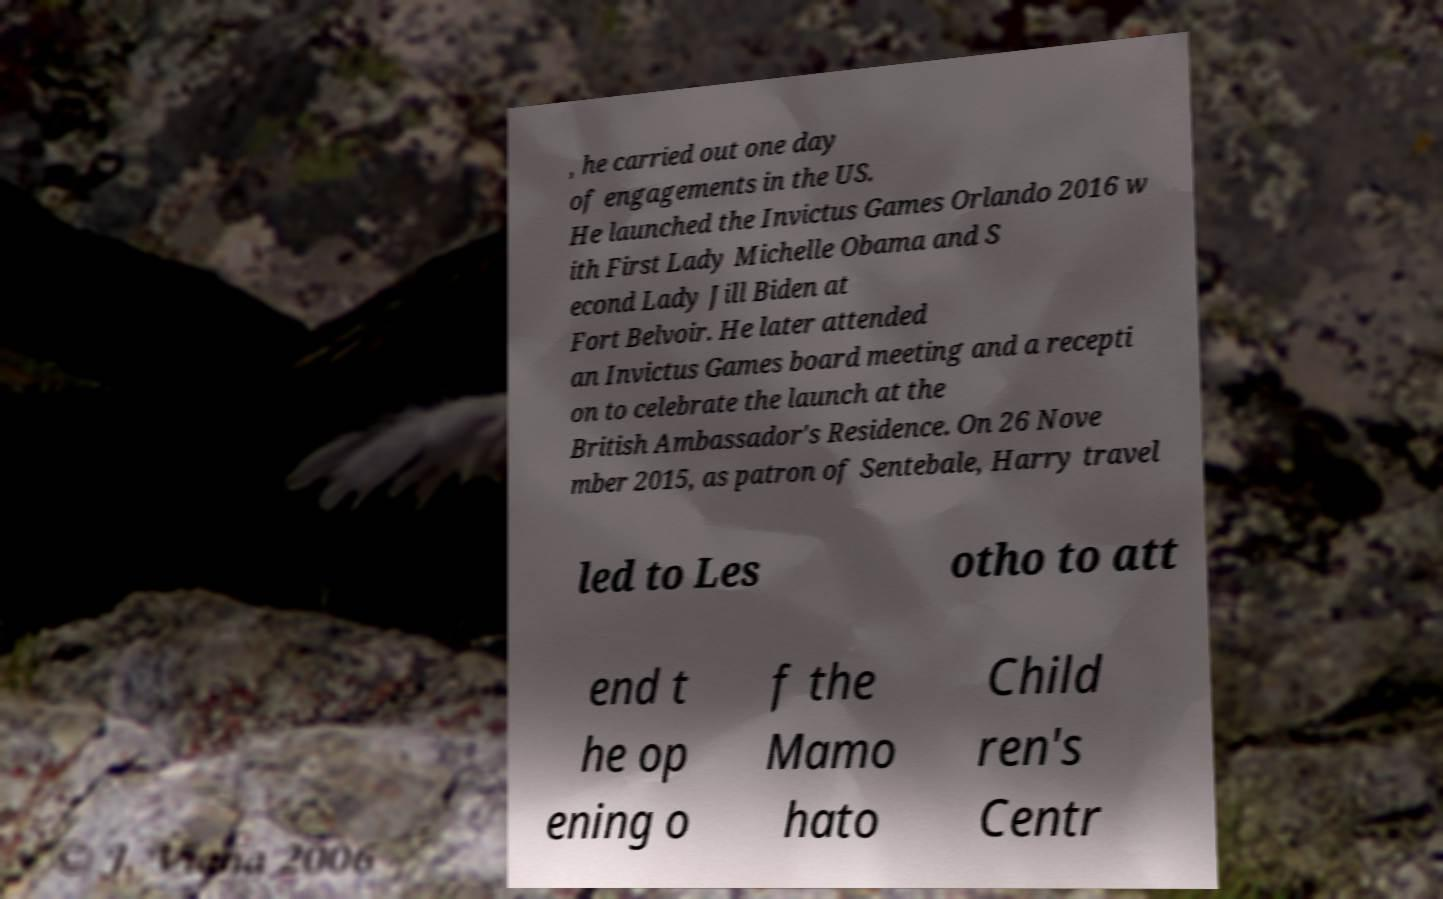I need the written content from this picture converted into text. Can you do that? , he carried out one day of engagements in the US. He launched the Invictus Games Orlando 2016 w ith First Lady Michelle Obama and S econd Lady Jill Biden at Fort Belvoir. He later attended an Invictus Games board meeting and a recepti on to celebrate the launch at the British Ambassador's Residence. On 26 Nove mber 2015, as patron of Sentebale, Harry travel led to Les otho to att end t he op ening o f the Mamo hato Child ren's Centr 